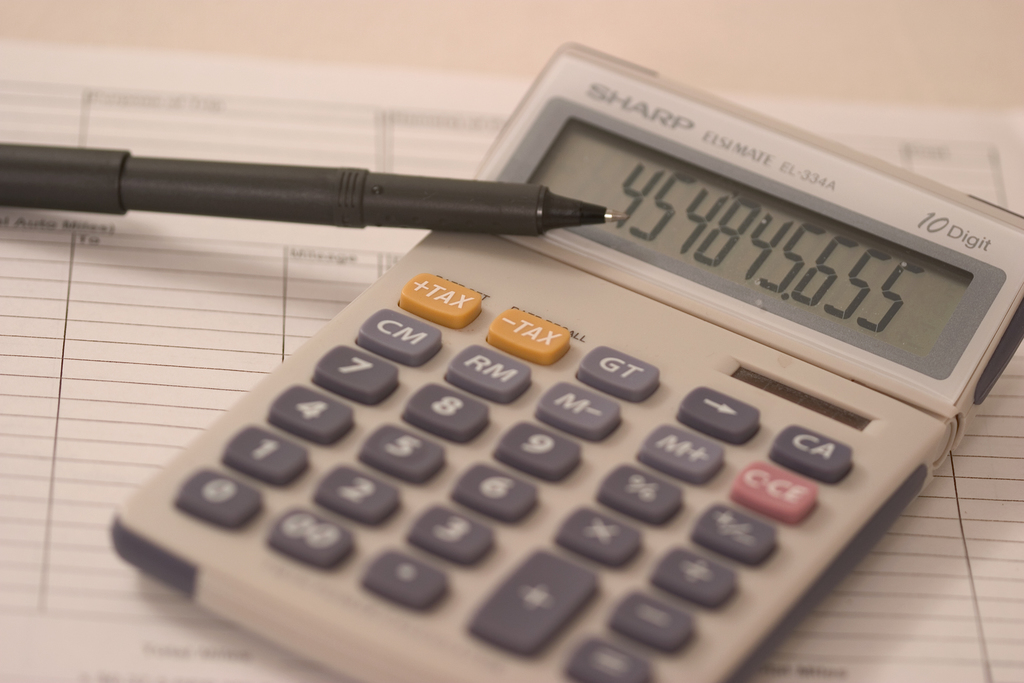Can you tell more about how an object like the Sharp EL-334A calculator is typically used in professional settings? The Sharp EL-334A calculator is designed primarily for business and tax calculations, making it a staple in many professional settings where handling financial data is frequent. It features dedicated keys for functions like tax calculations, making it highly efficient for tasks such as determining sales tax, deducting taxes from transactions, or applying discounts. Users often rely on such calculators for quick, accurate numerical entries during meetings, planning sessions, or typical office workflows where financial accuracy is crucial. 